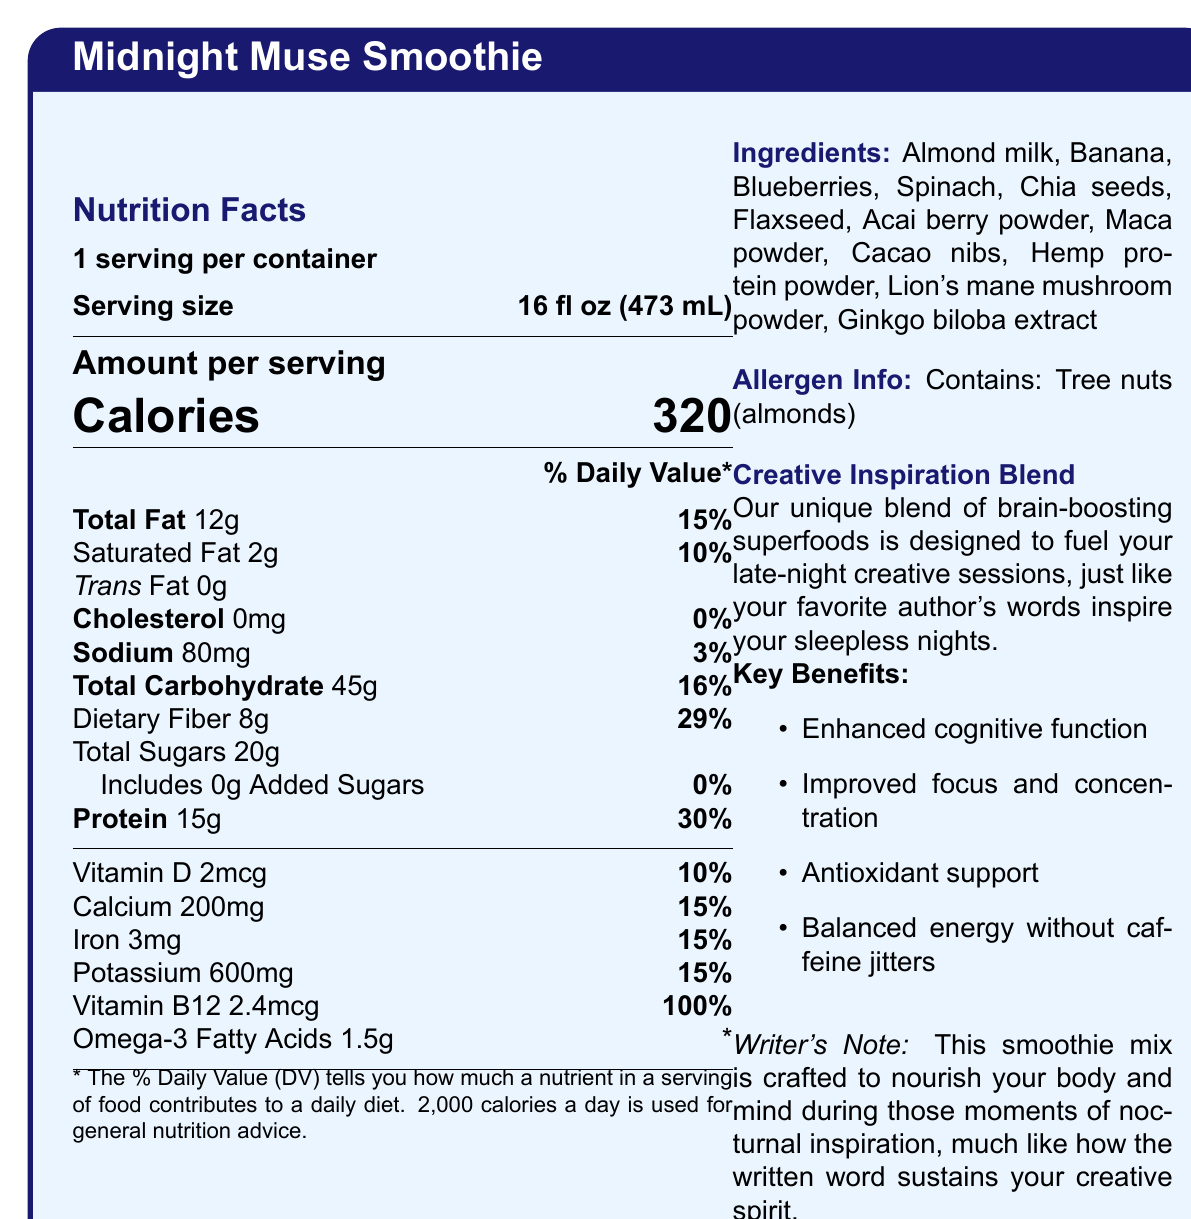What is the serving size of the Midnight Muse Smoothie? The serving size is clearly listed as 16 fl oz (473 mL) under the "Nutrition Facts".
Answer: 16 fl oz (473 mL) How many calories are in one serving of the Midnight Muse Smoothie? The calorie count is prominently displayed in large text in the "Nutrition Facts" section.
Answer: 320 What is the total fat content per serving? The total fat content is shown as 12g with a daily value percentage of 15%.
Answer: 12g How much dietary fiber does one serving contain? The dietary fiber content is listed as 8g with a daily value of 29%.
Answer: 8g What is the % Daily Value of Vitamin B12 in the smoothie? The % Daily Value of Vitamin B12 is shown as 100% in the "Nutrition Facts" section.
Answer: 100% What ingredients are present in the Midnight Muse Smoothie? The ingredients are listed on the right side under the "Ingredients" heading.
Answer: Almond milk, Banana, Blueberries, Spinach, Chia seeds, Flaxseed, Acai berry powder, Maca powder, Cacao nibs, Hemp protein powder, Lion's mane mushroom powder, Ginkgo biloba extract Which statement is true about the added sugars in the smoothie?
  A. It contains 10g of added sugars.
  B. It contains 0g of added sugars.
  C. It contains 5g of added sugars. The "Total Sugars" section includes a line stating that the smoothie contains 0g of added sugars.
Answer: B. It contains 0g of added sugars. What are the benefits of the "Creative Inspiration Blend"? 
  I. Enhanced cognitive function 
  II. Antioxidant support 
  III. Increased caffeine levels 
  IV. Improved focus and concentration The "Key Benefits" section mentions Enhanced cognitive function, Antioxidant support, and Improved focus and concentration but does not mention anything about increased caffeine levels.
Answer: I, II, IV Does the Midnight Muse Smoothie contain any cholesterol? The "Cholesterol" section shows 0mg, indicating that the smoothie contains no cholesterol.
Answer: No Summarize the purpose and qualities of the Midnight Muse Smoothie. The smoothie features detailed nutritional information and highlights its role in boosting cognitive function and energy for late-night creativity, without caffeine-related side effects.
Answer: The Midnight Muse Smoothie is designed to provide comprehensive nutrition with brain-boosting superfoods to fuel late-night creative sessions. It offers balanced energy without caffeine jitters, enhances cognitive function, improves focus and concentration, and provides antioxidant support. The smoothie is crafted to nourish both body and mind during moments of nocturnal inspiration. What is the color of the title header in the document? The visual information does not specify the color of the title header.
Answer: Cannot be determined What is the allergen information listed on the label? The allergen information is clearly noted as containing tree nuts (almonds).
Answer: Contains: Tree nuts (almonds) 